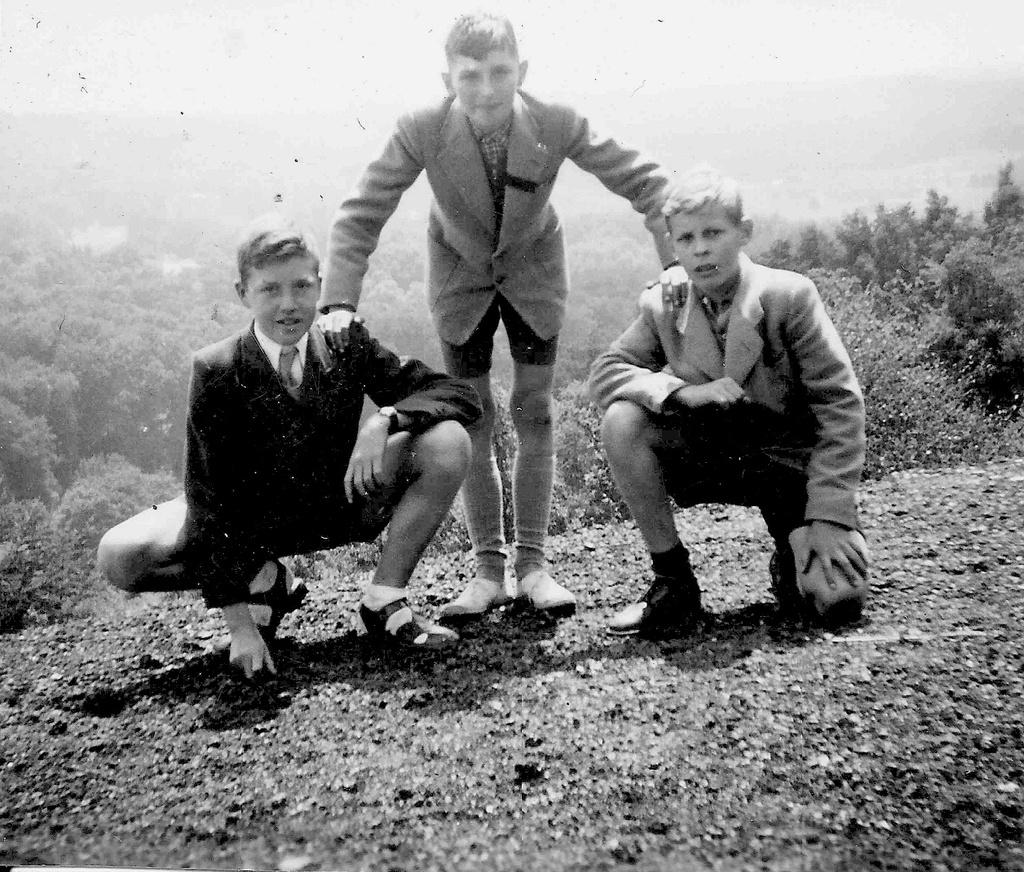How many people are in the image? There are three people in the image. What are the people wearing? The people are wearing dresses. What can be seen in the background of the image? There are many trees, mountains, clouds, and the sky visible in the background of the image. What is the tax rate for the room in the image? There is no mention of a room or tax rate in the image, as it features three people wearing dresses with a background of trees, mountains, clouds, and the sky. 